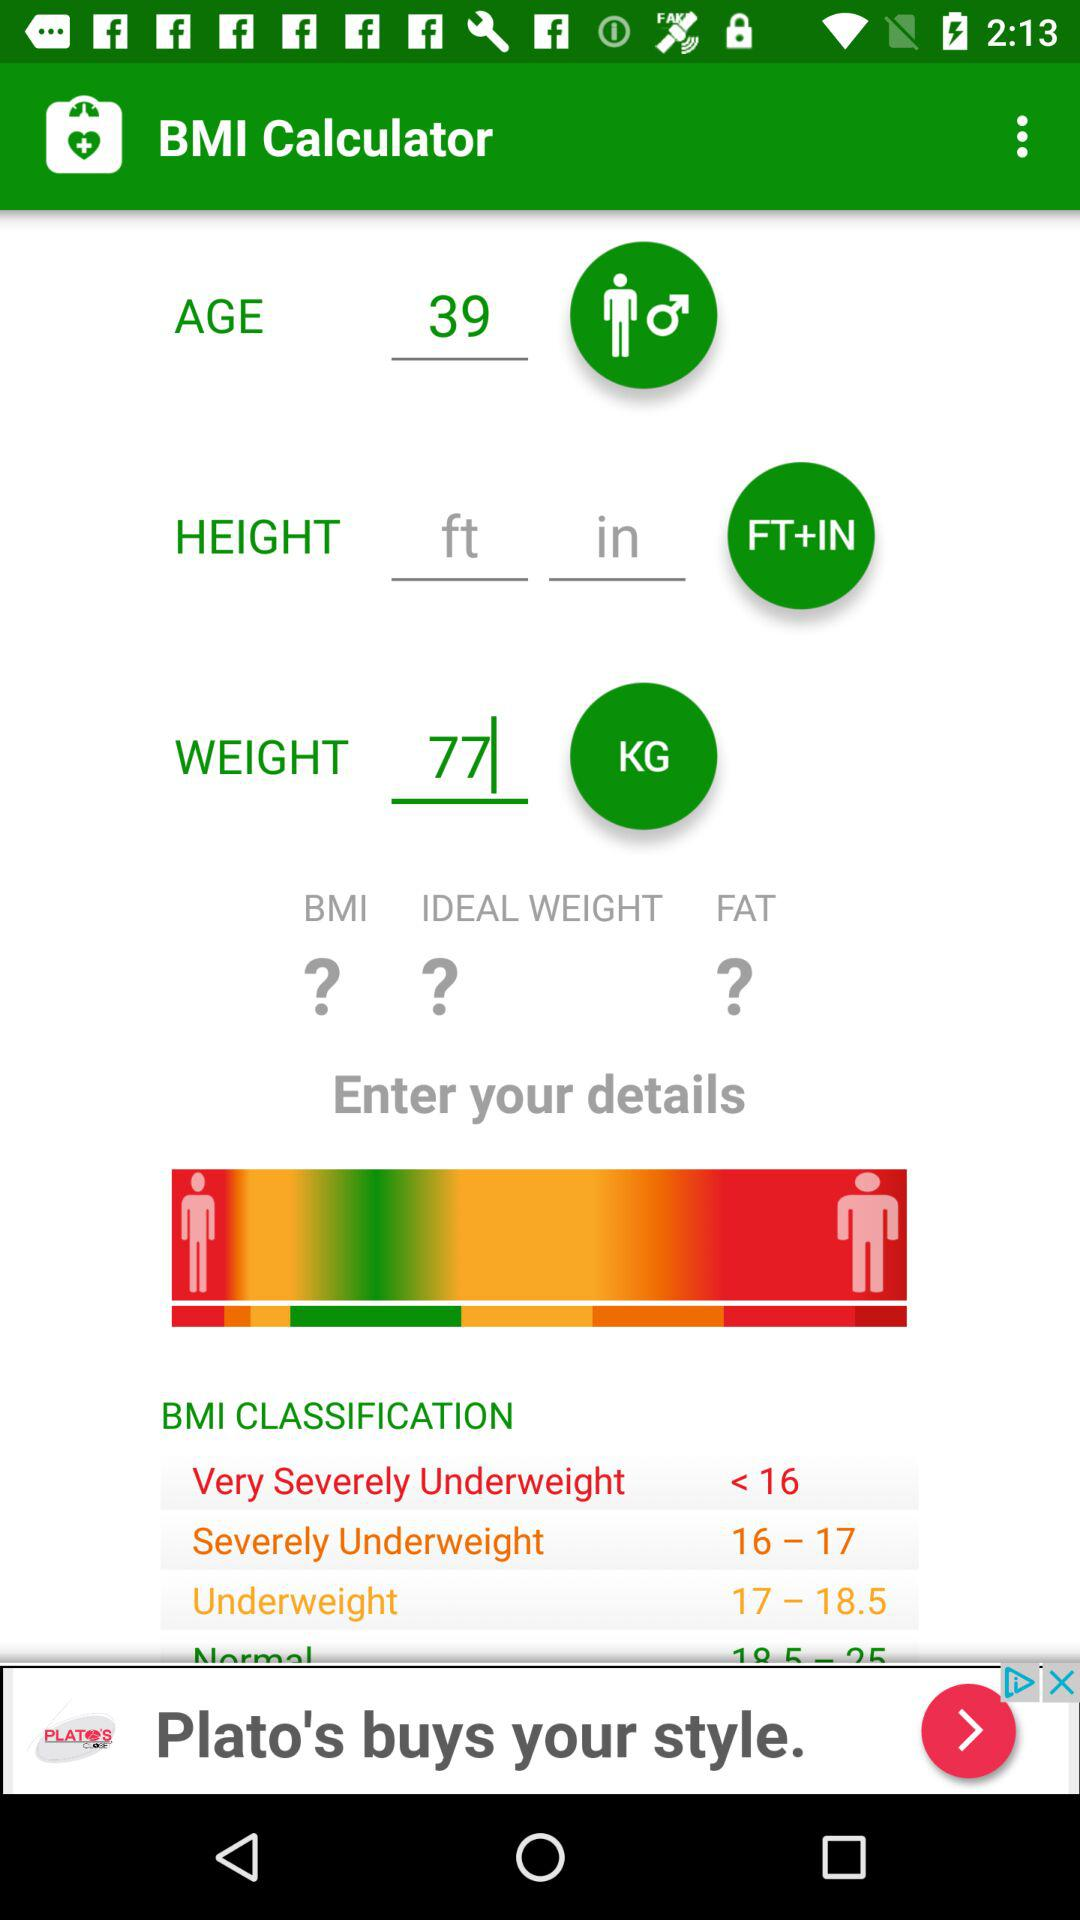What is the range mentioned for underweight? The mentioned range is from 17 to 18.5. 